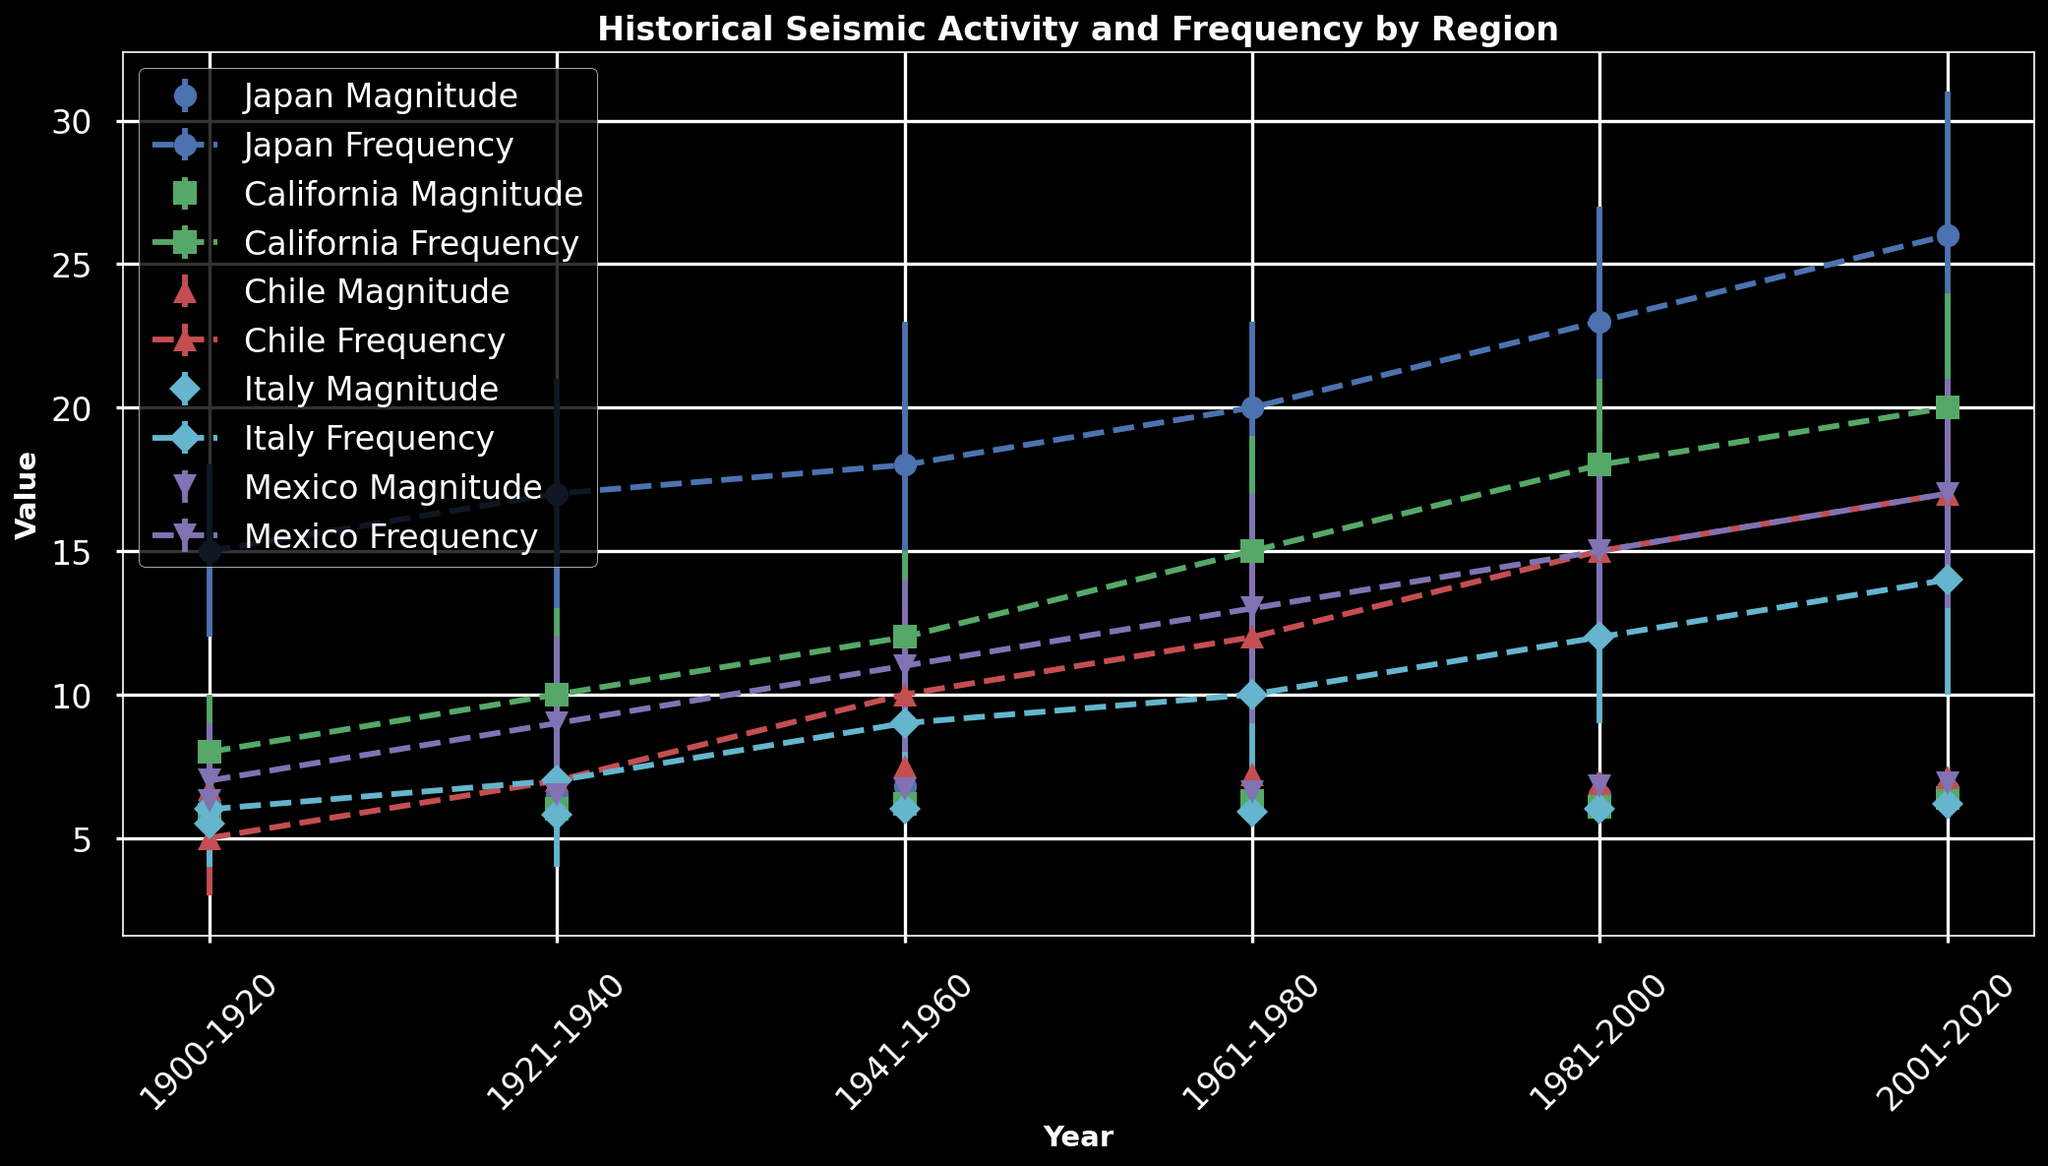Which region shows the greatest increase in average frequency per year over time? By observing the changing values of average frequency per year for each region across the years, we can see that Japan starts with an average frequency of 15 per year (1900-1920) and increases to 26 per year (2001-2020), showing the greatest increase among all regions.
Answer: Japan Which region has the highest average magnitude from 2001 to 2020? By comparing the average magnitudes for each region in the 2001-2020 period, we find that Chile has the highest average magnitude of 7.1.
Answer: Chile How does the average magnitude of earthquakes in California from 1941 to 1960 compare to that in Japan for the same period? The figure shows that the average magnitude in California from 1941 to 1960 is 6.2, whereas in Japan it is 6.8. Therefore, the average magnitude in Japan is higher than in California for that period.
Answer: Japan has a higher average magnitude What is the overall trend in earthquake frequency in Italy over the observed periods? Observing the data points for Italy, the average frequency increases gradually from 6 per year in 1900-1920 to 14 per year in 2001-2020, indicating an overall upward trend.
Answer: Upward trend During the period 1921-1940, which region had the smallest standard deviation in earthquake frequency, and what is its value? The figure shows that during the period 1921-1940, Japan has the smallest standard deviation in earthquake frequency, with a value of 4.
Answer: Japan, 4 Consider the period from 1981-2000 for Chile and Mexico. Which region had more frequent earthquakes on average, and by how much? In the period from 1981-2000, Chile had an average frequency of 15 earthquakes per year, whereas Mexico had 17. Thus, Mexico had 2 more earthquakes on average than Chile in that period.
Answer: Mexico, by 2 What is the combined average magnitude for Japan and Mexico for the period 2001-2020? The average magnitude for Japan for 2001-2020 is 6.7, and for Mexico, it is 6.9. The combined average magnitude is calculated as (6.7 + 6.9) / 2 = 6.8.
Answer: 6.8 Which region has the most consistent earthquake magnitudes (i.e., smallest standard deviation) in the period from 2001 to 2020, and what is the value? Observing the figure, Japan has the smallest standard deviation in earthquake magnitudes during 2001-2020 with a value of 0.2.
Answer: Japan, 0.2 Which region experienced a decrease in earthquake magnitude from 1961-1980 to 1981-2000, and what is the magnitude of the decrease? In the period from 1961-1980, Japan's average magnitude was 6.3, and it increased to 6.5 in the next period (1981-2000); however, searching all other regions, California's magnitude decreases from 6.3 to 6.1, showing a difference of 0.2.
Answer: California, 0.2 